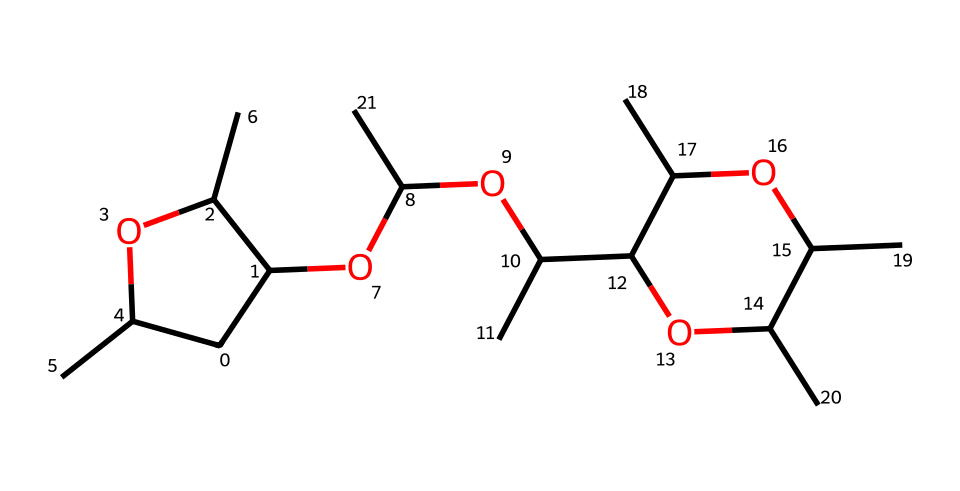What is the base structure of metaldehyde? The chemical has a core structure made of a cyclic ether with substituents. The presence of the ring indicates that it is a cyclic compound, which is typical for pesticides.
Answer: cyclic ether How many carbon atoms are in metaldehyde? By analyzing the SMILES representation, we can count each carbon atom explicitly mentioned, including those in branches, resulting in a total of 12 carbon atoms.
Answer: 12 What functional groups are present in metaldehyde? The compound features both ether and alcohol functional groups as indicated by –O– linkages and –OH groups in its structure, typical for this category of pesticides.
Answer: ether and alcohol Does metaldehyde contain any nitrogen atoms? Upon examining the structure, there are no nitrogen atoms present, as the chemical formula and SMILES do not indicate any nitrogen-containing groups.
Answer: no What is the main use of metaldehyde? Metaldehyde is predominantly utilized as a molluscicide in agricultural practices, indicating its function to protect crops and equipment from slugs and snails.
Answer: molluscicide How does the structure of metaldehyde suggest its mechanism of action? The cyclic structure influences how the compound interacts with biological systems, suggesting it disrupts biological processes in slugs, an important factor in its effectiveness as a pesticide.
Answer: disrupts biological processes What physical state is metaldehyde typically found in at room temperature? Metaldehyde is usually found as a solid at room temperature, as indicated by its molecular structure and typical storage conditions used for solid pesticides.
Answer: solid 